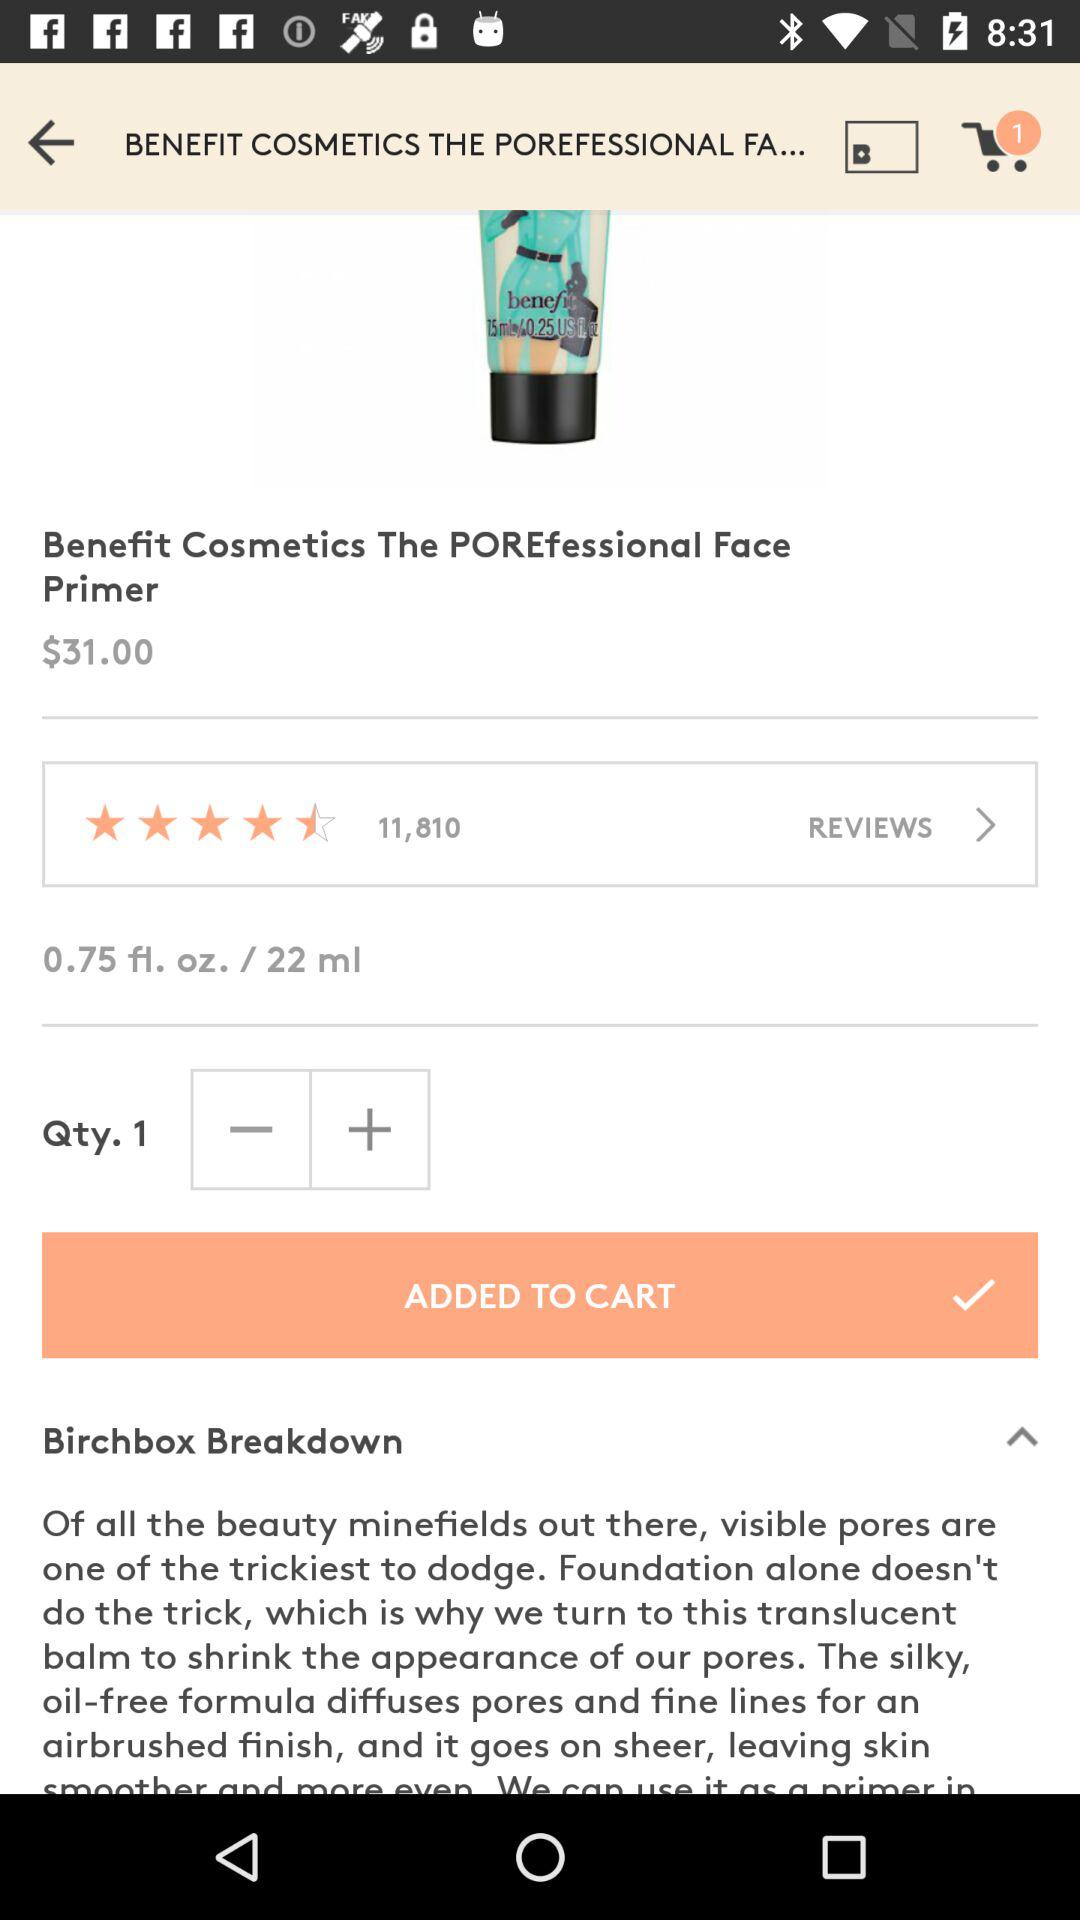What is the price of the product? The price is $31. 